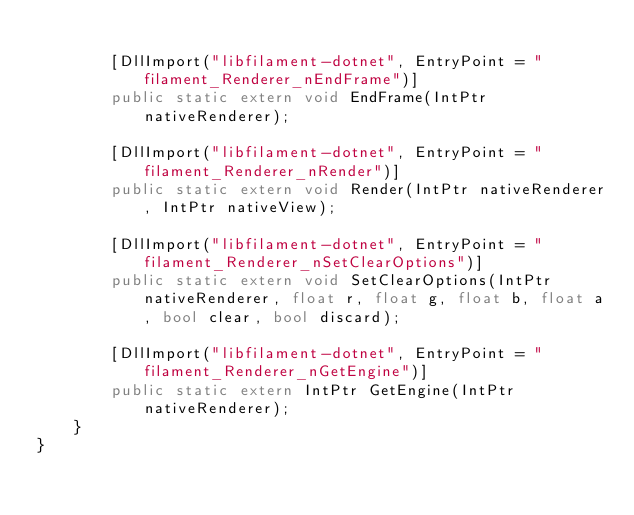<code> <loc_0><loc_0><loc_500><loc_500><_C#_>
        [DllImport("libfilament-dotnet", EntryPoint = "filament_Renderer_nEndFrame")]
        public static extern void EndFrame(IntPtr nativeRenderer);

        [DllImport("libfilament-dotnet", EntryPoint = "filament_Renderer_nRender")]
        public static extern void Render(IntPtr nativeRenderer, IntPtr nativeView);

        [DllImport("libfilament-dotnet", EntryPoint = "filament_Renderer_nSetClearOptions")]
        public static extern void SetClearOptions(IntPtr nativeRenderer, float r, float g, float b, float a, bool clear, bool discard);

        [DllImport("libfilament-dotnet", EntryPoint = "filament_Renderer_nGetEngine")]
        public static extern IntPtr GetEngine(IntPtr nativeRenderer);
    }
}
</code> 